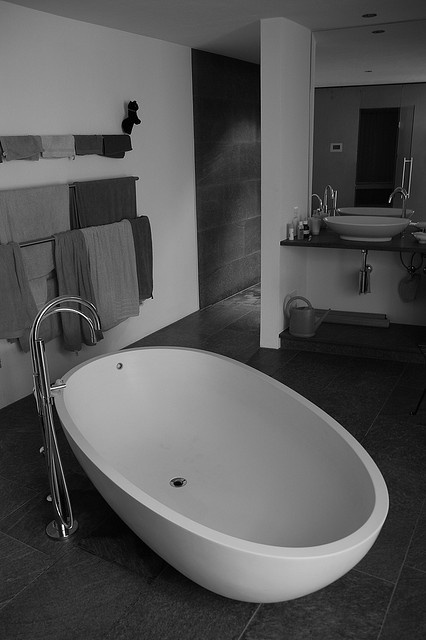Describe the objects in this image and their specific colors. I can see sink in gray, black, and darkgray tones, sink in black and gray tones, bottle in gray and black tones, bottle in black and gray tones, and bottle in gray and black tones in this image. 